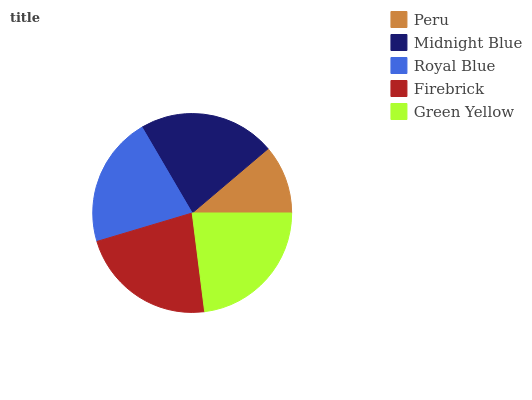Is Peru the minimum?
Answer yes or no. Yes. Is Green Yellow the maximum?
Answer yes or no. Yes. Is Midnight Blue the minimum?
Answer yes or no. No. Is Midnight Blue the maximum?
Answer yes or no. No. Is Midnight Blue greater than Peru?
Answer yes or no. Yes. Is Peru less than Midnight Blue?
Answer yes or no. Yes. Is Peru greater than Midnight Blue?
Answer yes or no. No. Is Midnight Blue less than Peru?
Answer yes or no. No. Is Midnight Blue the high median?
Answer yes or no. Yes. Is Midnight Blue the low median?
Answer yes or no. Yes. Is Firebrick the high median?
Answer yes or no. No. Is Peru the low median?
Answer yes or no. No. 